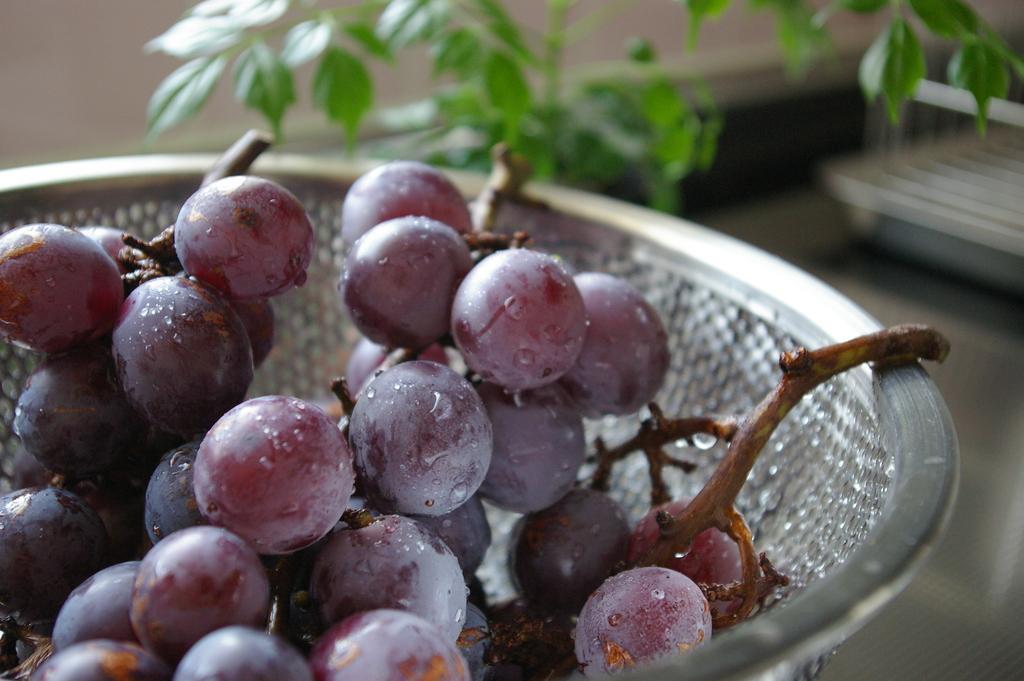Please provide a concise description of this image. In the center of the image there is a bowl with grapes in it. At the background of the image there is some plant. 